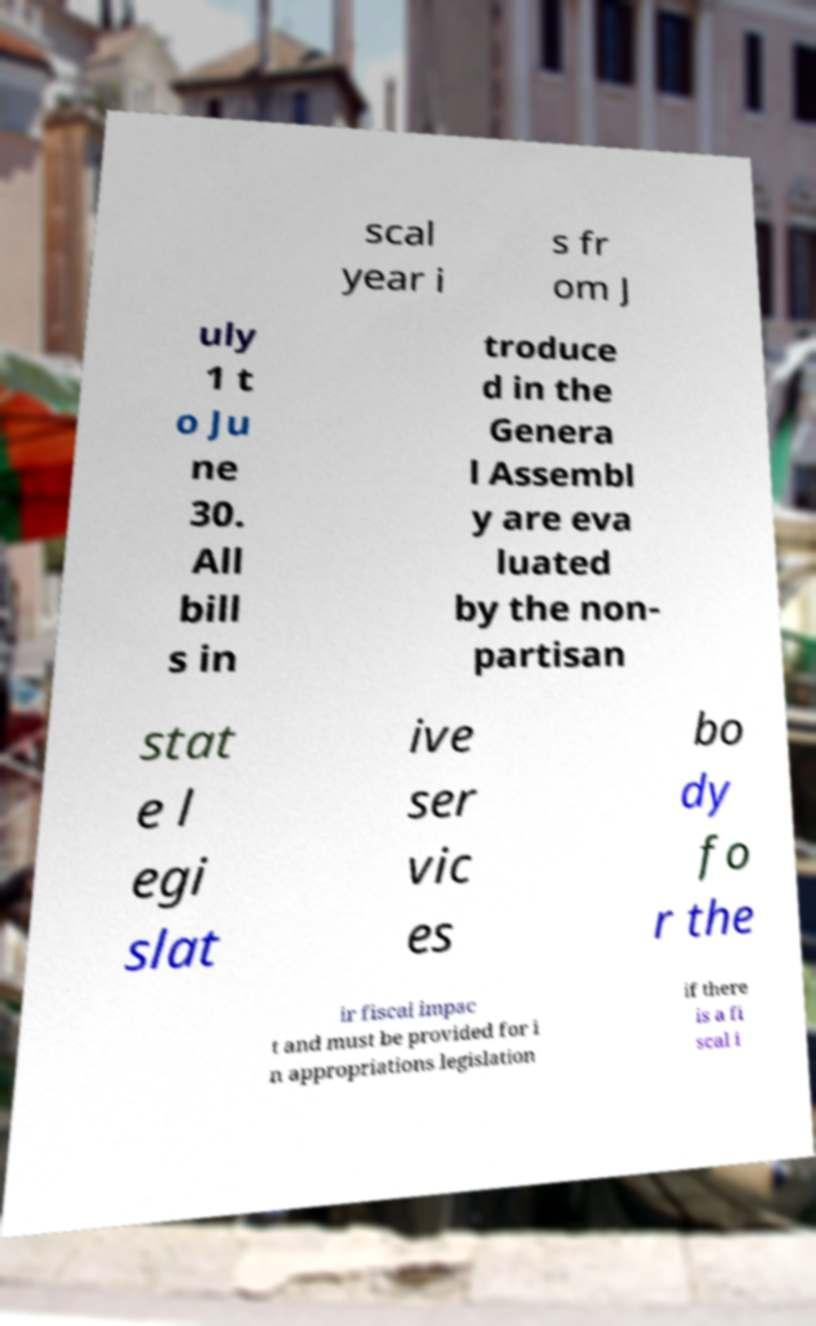Please identify and transcribe the text found in this image. scal year i s fr om J uly 1 t o Ju ne 30. All bill s in troduce d in the Genera l Assembl y are eva luated by the non- partisan stat e l egi slat ive ser vic es bo dy fo r the ir fiscal impac t and must be provided for i n appropriations legislation if there is a fi scal i 